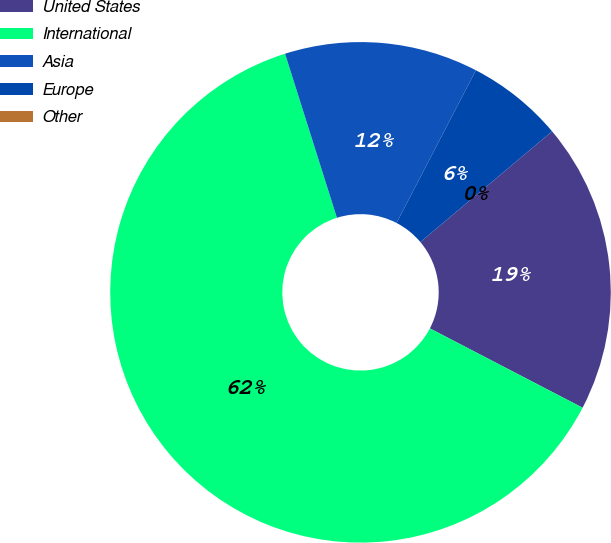<chart> <loc_0><loc_0><loc_500><loc_500><pie_chart><fcel>United States<fcel>International<fcel>Asia<fcel>Europe<fcel>Other<nl><fcel>18.75%<fcel>62.5%<fcel>12.5%<fcel>6.25%<fcel>0.0%<nl></chart> 